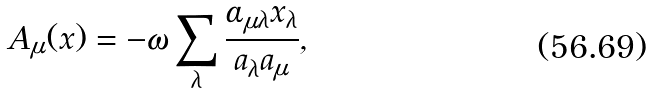<formula> <loc_0><loc_0><loc_500><loc_500>A _ { \mu } ( x ) = - \omega \sum _ { \lambda } \frac { \alpha _ { \mu \lambda } x _ { \lambda } } { a _ { \lambda } a _ { \mu } } ,</formula> 